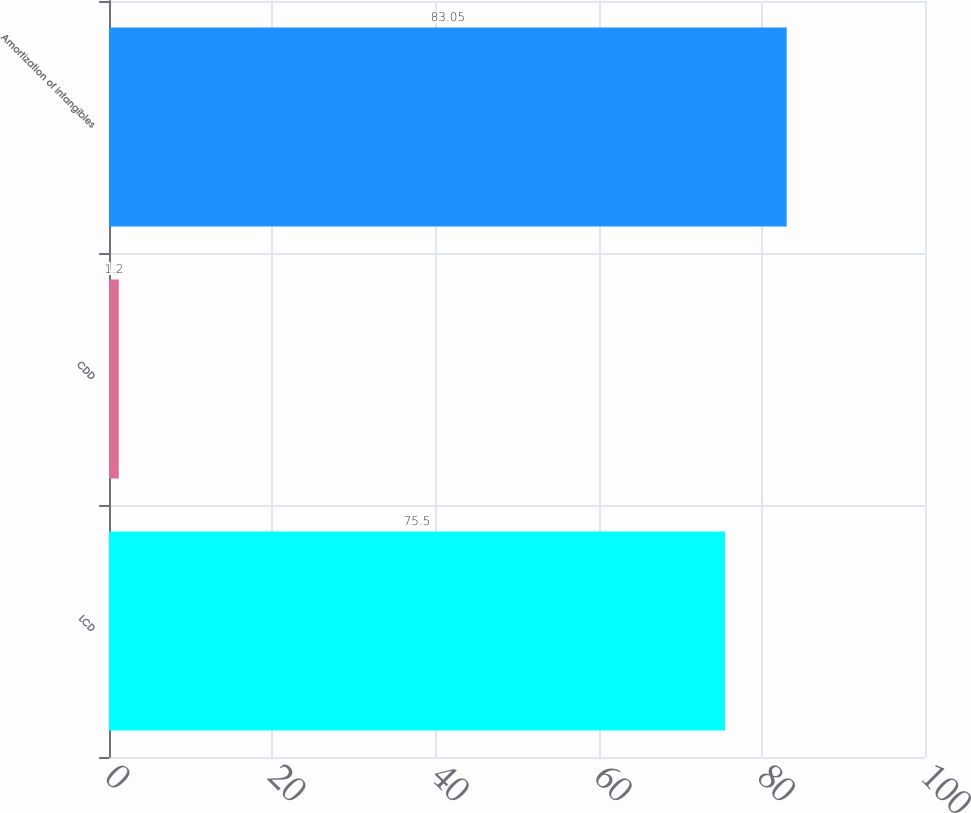Convert chart. <chart><loc_0><loc_0><loc_500><loc_500><bar_chart><fcel>LCD<fcel>CDD<fcel>Amortization of intangibles<nl><fcel>75.5<fcel>1.2<fcel>83.05<nl></chart> 